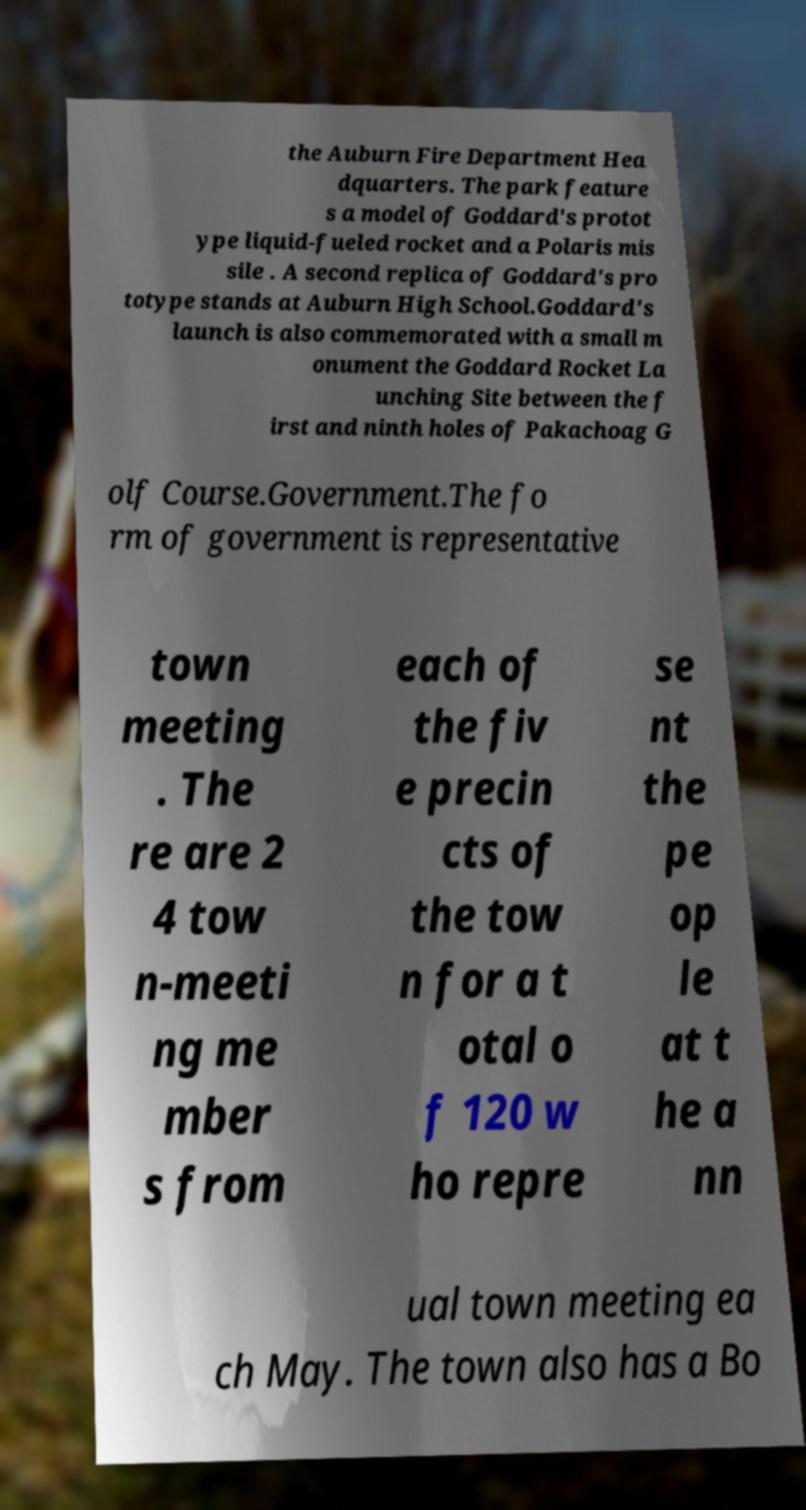Can you accurately transcribe the text from the provided image for me? the Auburn Fire Department Hea dquarters. The park feature s a model of Goddard's protot ype liquid-fueled rocket and a Polaris mis sile . A second replica of Goddard's pro totype stands at Auburn High School.Goddard's launch is also commemorated with a small m onument the Goddard Rocket La unching Site between the f irst and ninth holes of Pakachoag G olf Course.Government.The fo rm of government is representative town meeting . The re are 2 4 tow n-meeti ng me mber s from each of the fiv e precin cts of the tow n for a t otal o f 120 w ho repre se nt the pe op le at t he a nn ual town meeting ea ch May. The town also has a Bo 